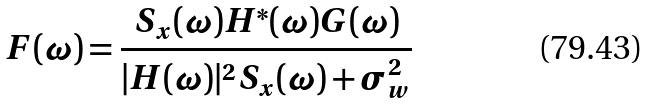Convert formula to latex. <formula><loc_0><loc_0><loc_500><loc_500>F ( \omega ) = \frac { S _ { x } ( \omega ) H ^ { * } ( \omega ) G ( \omega ) } { | H ( \omega ) | ^ { 2 } S _ { x } ( \omega ) + \sigma _ { w } ^ { 2 } }</formula> 